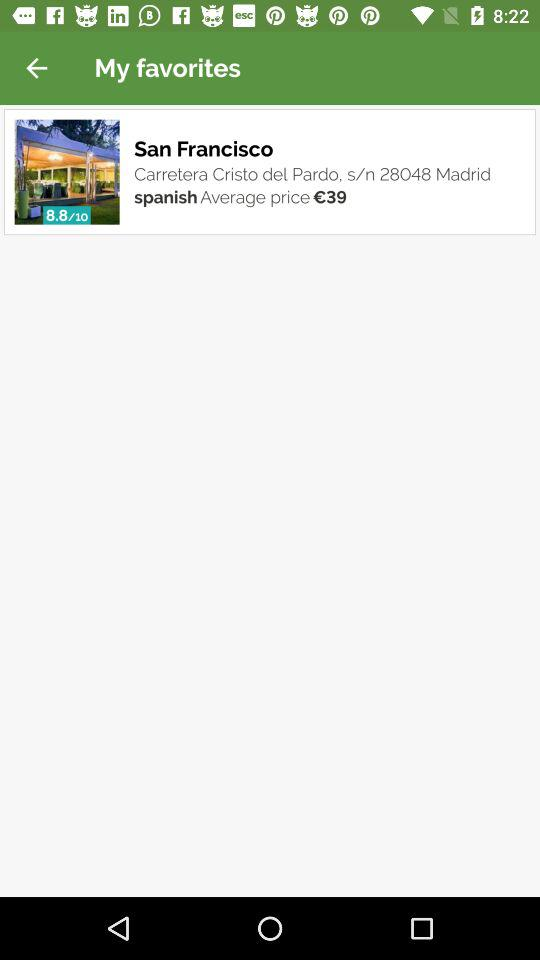What is the average price of the restaurant?
Answer the question using a single word or phrase. €39 